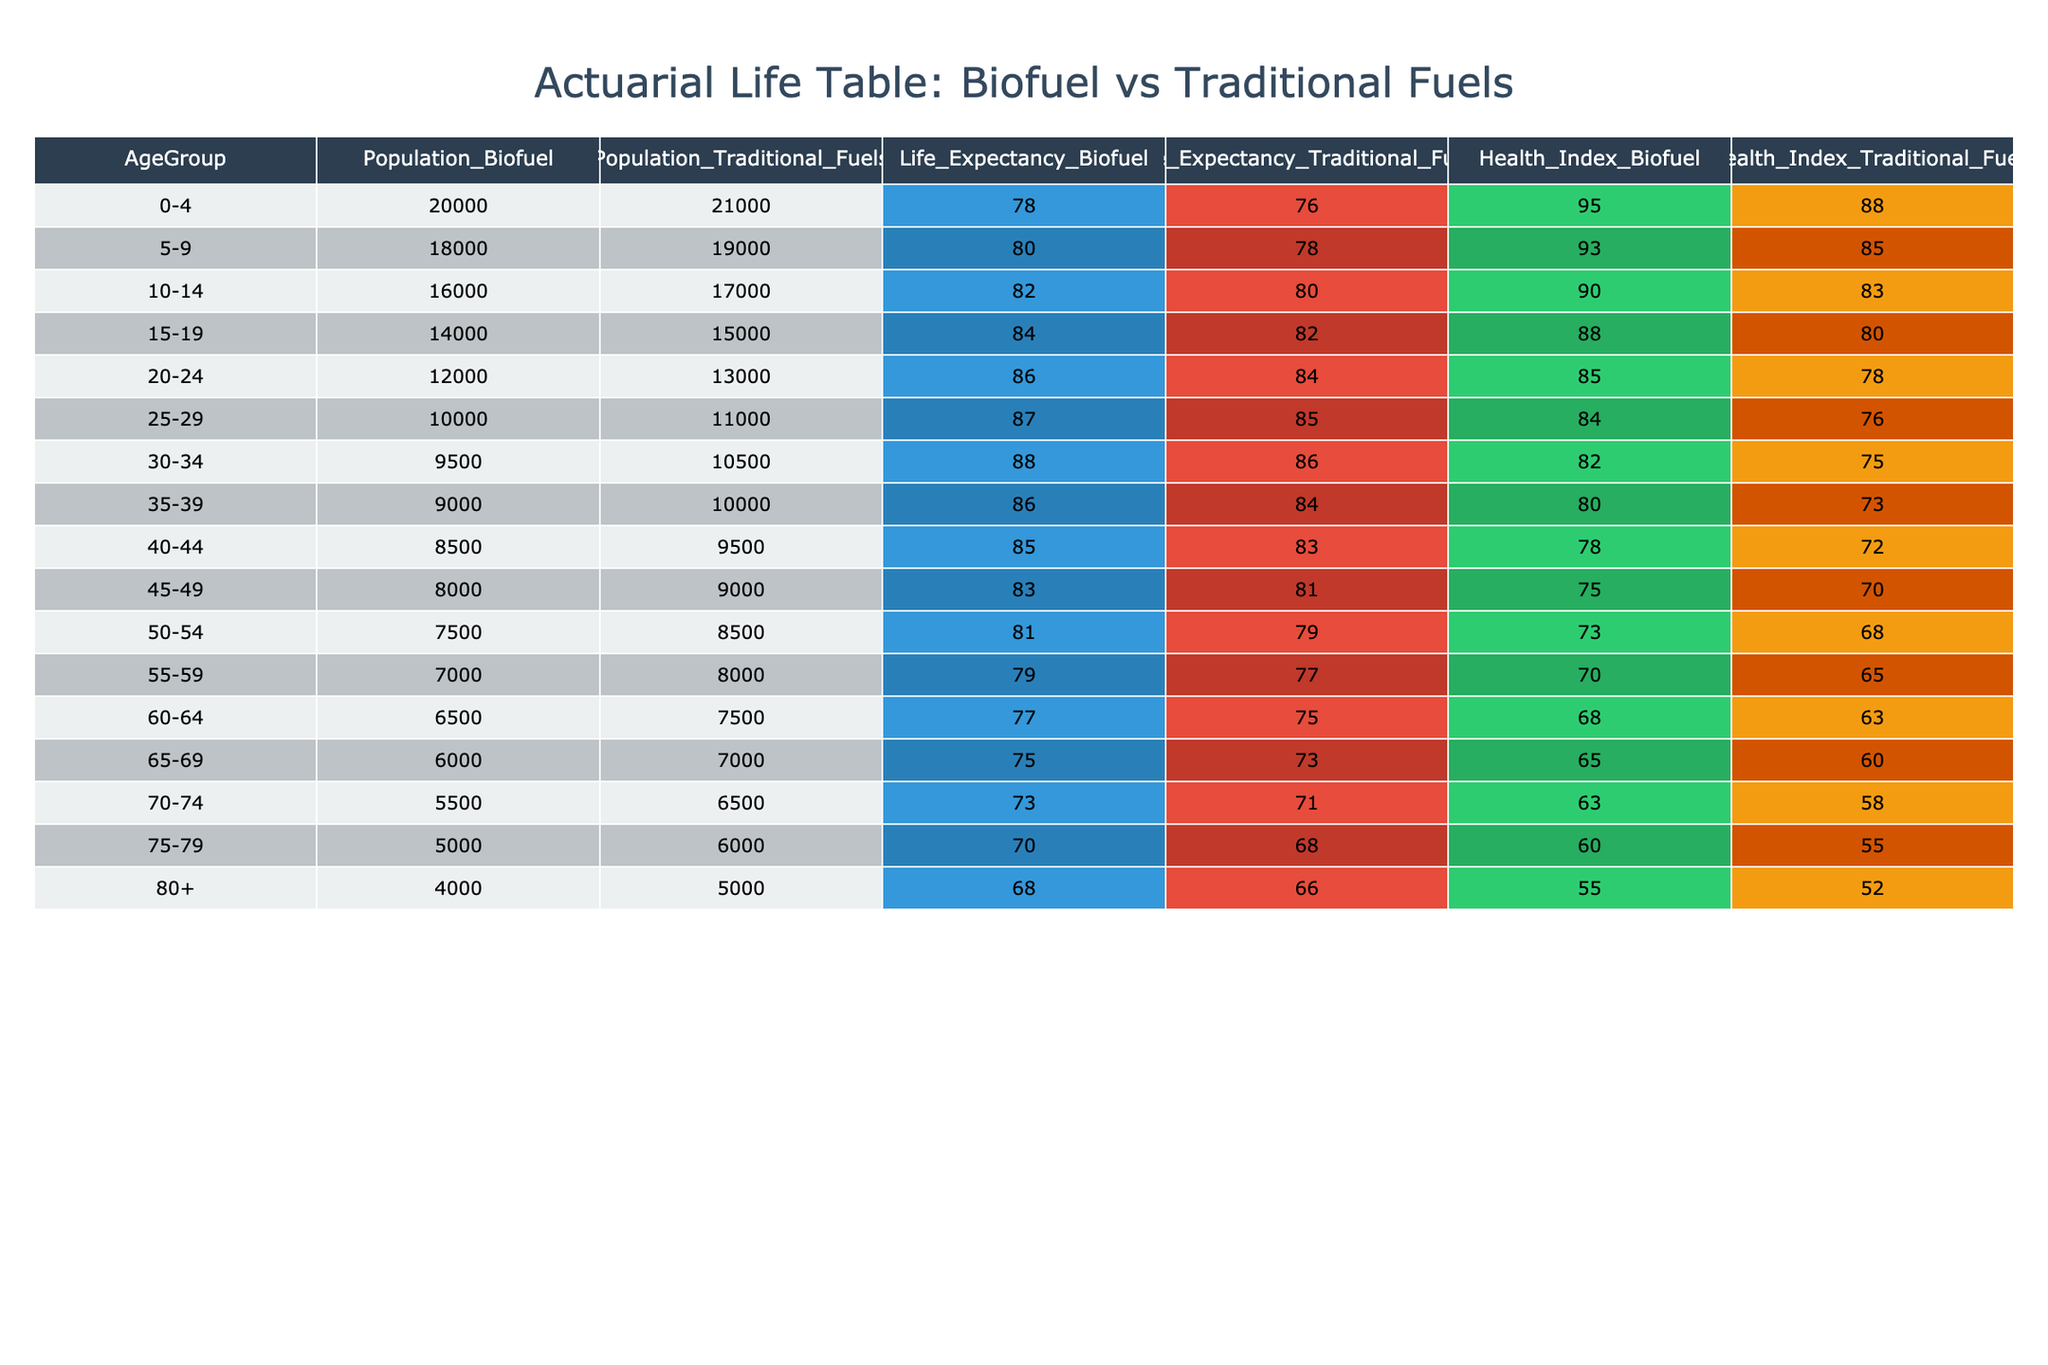What is the life expectancy for the population consuming biofuel in the age group 40-44? According to the table, the life expectancy for the population consuming biofuel in the age group 40-44 is listed directly as 85 years.
Answer: 85 What is the health index for the population using traditional fuels in the age group 70-74? The table shows that the health index for the population using traditional fuels in the age group 70-74 is 58.
Answer: 58 How many individuals are in the age group 30-34 consuming biofuel products? The table lists 9,500 individuals in the age group 30-34 consuming biofuel products.
Answer: 9500 What is the difference in life expectancy between the biofuel and traditional fuels populations for the age group 25-29? For the age group 25-29, the life expectancy for the biofuel population is 87 and for traditional fuels is 85. The difference is 87 - 85 = 2.
Answer: 2 Which age group has the highest health index for traditional fuels? Looking at the health index values for traditional fuels, the age group 0-4 has the highest health index at 88.
Answer: 0-4 What is the average life expectancy for the biofuel populations across all age groups listed? To find the average life expectancy, sum all the values for biofuel (78 + 80 + 82 + 84 + 86 + 87 + 88 + 86 + 85 + 83 + 81 + 79 + 77 + 75 + 73 + 70 + 68) = 1356 and there are 17 groups, so the average is 1356 / 17 = 79.6.
Answer: 79.6 Is the health index for the age group 55-59 higher in biofuel consumers compared to traditional fuel consumers? The health index for the biofuel population in the 55-59 age group is 70, while for traditional fuels it is 65. Thus, the health index for biofuel consumers is higher.
Answer: Yes For the 80+ age group, what is the health index for those consuming biofuel? The health index for individuals in the 80+ age group consuming biofuel is 55, as indicated in the table.
Answer: 55 What is the total population consuming biofuel across all age groups? The total population consuming biofuel is calculated by summing all the individuals from each age group: (20000 + 18000 + 16000 + 14000 + 12000 + 10000 + 9500 + 9000 + 8500 + 8000 + 7500 + 7000 + 6500 + 6000 + 5500 + 5000 + 4000) = 145000.
Answer: 145000 